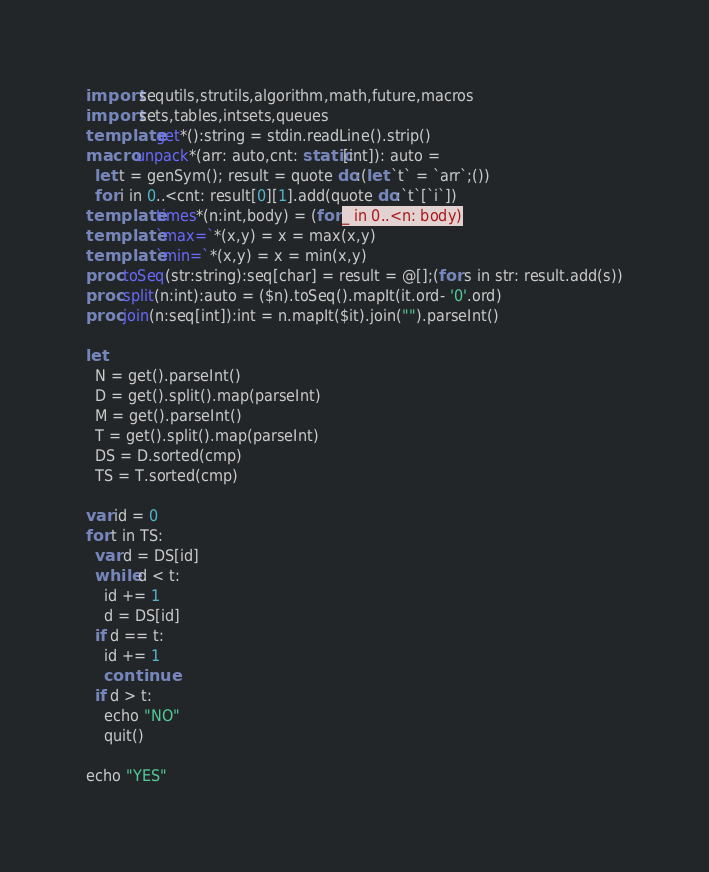Convert code to text. <code><loc_0><loc_0><loc_500><loc_500><_Nim_>import sequtils,strutils,algorithm,math,future,macros
import sets,tables,intsets,queues
template get*():string = stdin.readLine().strip()
macro unpack*(arr: auto,cnt: static[int]): auto =
  let t = genSym(); result = quote do:(let `t` = `arr`;())
  for i in 0..<cnt: result[0][1].add(quote do:`t`[`i`])
template times*(n:int,body) = (for _ in 0..<n: body)
template `max=`*(x,y) = x = max(x,y)
template `min=`*(x,y) = x = min(x,y)
proc toSeq(str:string):seq[char] = result = @[];(for s in str: result.add(s))
proc split(n:int):auto = ($n).toSeq().mapIt(it.ord- '0'.ord)
proc join(n:seq[int]):int = n.mapIt($it).join("").parseInt()

let
  N = get().parseInt()
  D = get().split().map(parseInt)
  M = get().parseInt()
  T = get().split().map(parseInt)
  DS = D.sorted(cmp)
  TS = T.sorted(cmp)

var id = 0
for t in TS:
  var d = DS[id]
  while d < t:
    id += 1
    d = DS[id]
  if d == t:
    id += 1
    continue
  if d > t:
    echo "NO"
    quit()

echo "YES"

</code> 